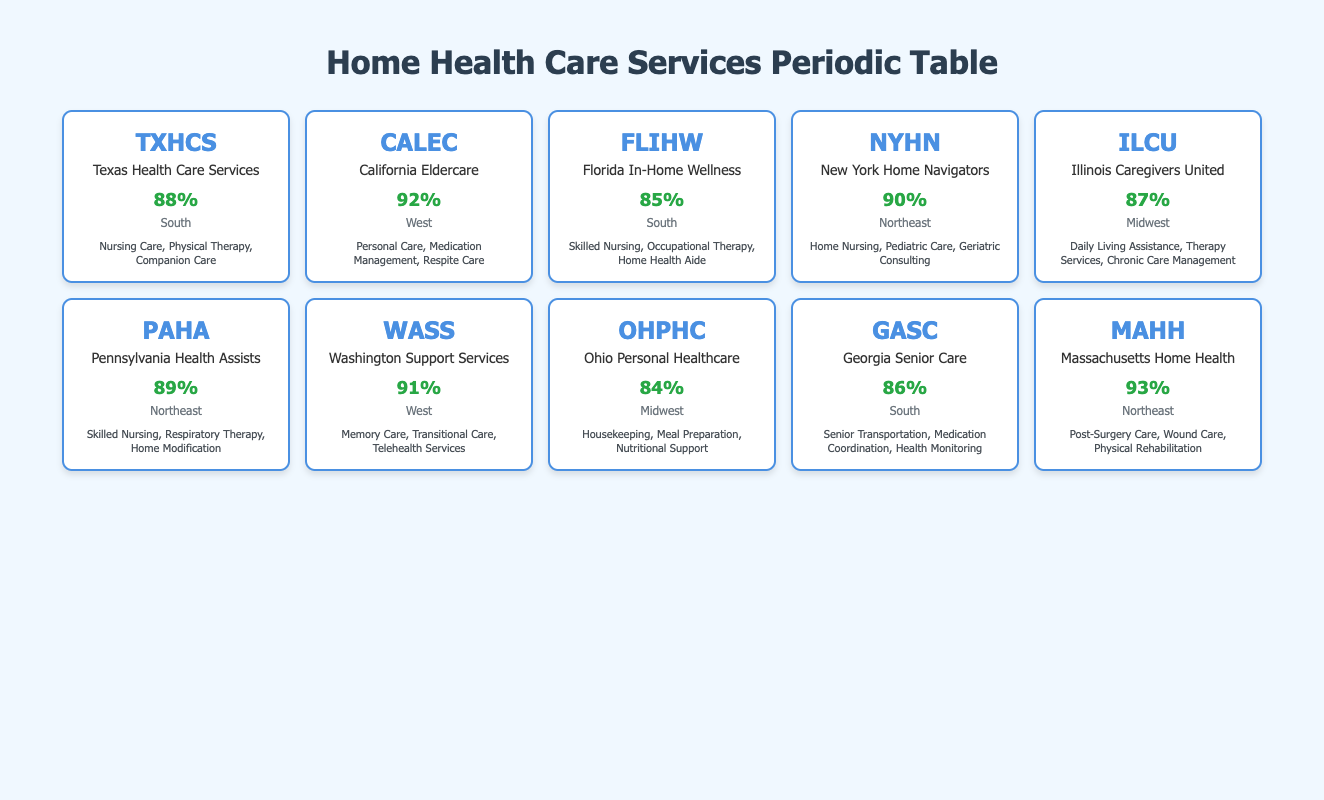What is the client satisfaction score for Pennsylvania Health Assists? The table indicates that the Client Satisfaction Score for Pennsylvania Health Assists is 89%. This can be found by locating the row corresponding to Pennsylvania Health Assists and checking the score listed.
Answer: 89% Which service types are provided by California Eldercare? According to the table, California Eldercare provides the following service types: Personal Care, Medication Management, and Respite Care. This information is found by looking at the row for California Eldercare and checking the service types listed.
Answer: Personal Care, Medication Management, Respite Care What is the average client satisfaction score for services in the Northeast region? The client satisfaction scores for the Northeast region are 90% (New York Home Navigators), 89% (Pennsylvania Health Assists), and 93% (Massachusetts Home Health). The total of these scores is 90 + 89 + 93 = 272, and there are 3 services, so the average score is calculated as 272 / 3 = 90.67%.
Answer: 90.67% Is the client satisfaction score for Texas Health Care Services higher than that for Ohio Personal Healthcare? The table shows that Texas Health Care Services has a score of 88%, while Ohio Personal Healthcare has a score of 84%. Since 88 is greater than 84, the statement is true.
Answer: Yes Which region has the highest client satisfaction score among the listed agencies? On examining the table, Massachusetts Home Health (Northeast) has the highest client satisfaction score at 93%. This is determined by comparing all the scores across different regions and identifying the maximum value.
Answer: Northeast 